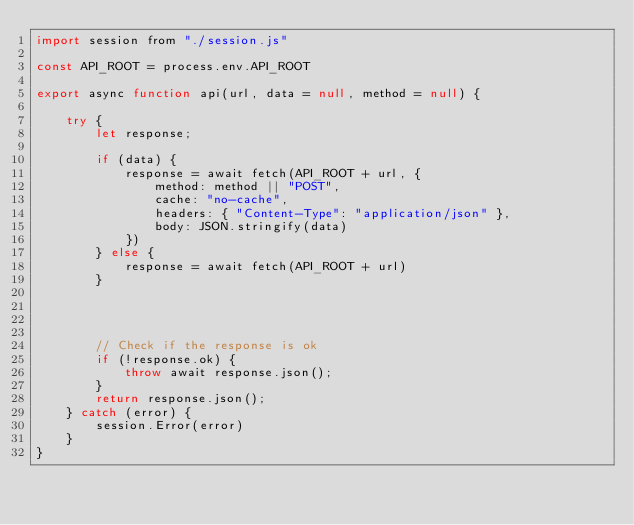Convert code to text. <code><loc_0><loc_0><loc_500><loc_500><_JavaScript_>import session from "./session.js"

const API_ROOT = process.env.API_ROOT

export async function api(url, data = null, method = null) {

    try {
        let response;

        if (data) {
            response = await fetch(API_ROOT + url, {
                method: method || "POST",
                cache: "no-cache",
                headers: { "Content-Type": "application/json" },
                body: JSON.stringify(data)
            })
        } else {
            response = await fetch(API_ROOT + url)
        }




        // Check if the response is ok
        if (!response.ok) {
            throw await response.json();
        }
        return response.json();
    } catch (error) {
        session.Error(error)
    }
}
</code> 